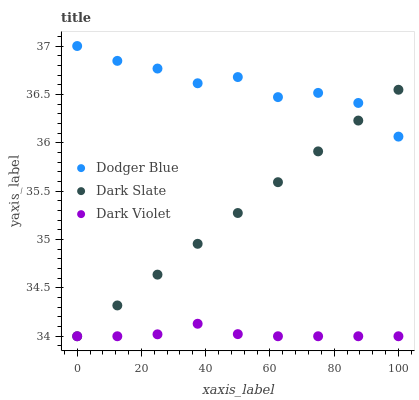Does Dark Violet have the minimum area under the curve?
Answer yes or no. Yes. Does Dodger Blue have the maximum area under the curve?
Answer yes or no. Yes. Does Dodger Blue have the minimum area under the curve?
Answer yes or no. No. Does Dark Violet have the maximum area under the curve?
Answer yes or no. No. Is Dark Slate the smoothest?
Answer yes or no. Yes. Is Dodger Blue the roughest?
Answer yes or no. Yes. Is Dark Violet the smoothest?
Answer yes or no. No. Is Dark Violet the roughest?
Answer yes or no. No. Does Dark Slate have the lowest value?
Answer yes or no. Yes. Does Dodger Blue have the lowest value?
Answer yes or no. No. Does Dodger Blue have the highest value?
Answer yes or no. Yes. Does Dark Violet have the highest value?
Answer yes or no. No. Is Dark Violet less than Dodger Blue?
Answer yes or no. Yes. Is Dodger Blue greater than Dark Violet?
Answer yes or no. Yes. Does Dark Slate intersect Dark Violet?
Answer yes or no. Yes. Is Dark Slate less than Dark Violet?
Answer yes or no. No. Is Dark Slate greater than Dark Violet?
Answer yes or no. No. Does Dark Violet intersect Dodger Blue?
Answer yes or no. No. 